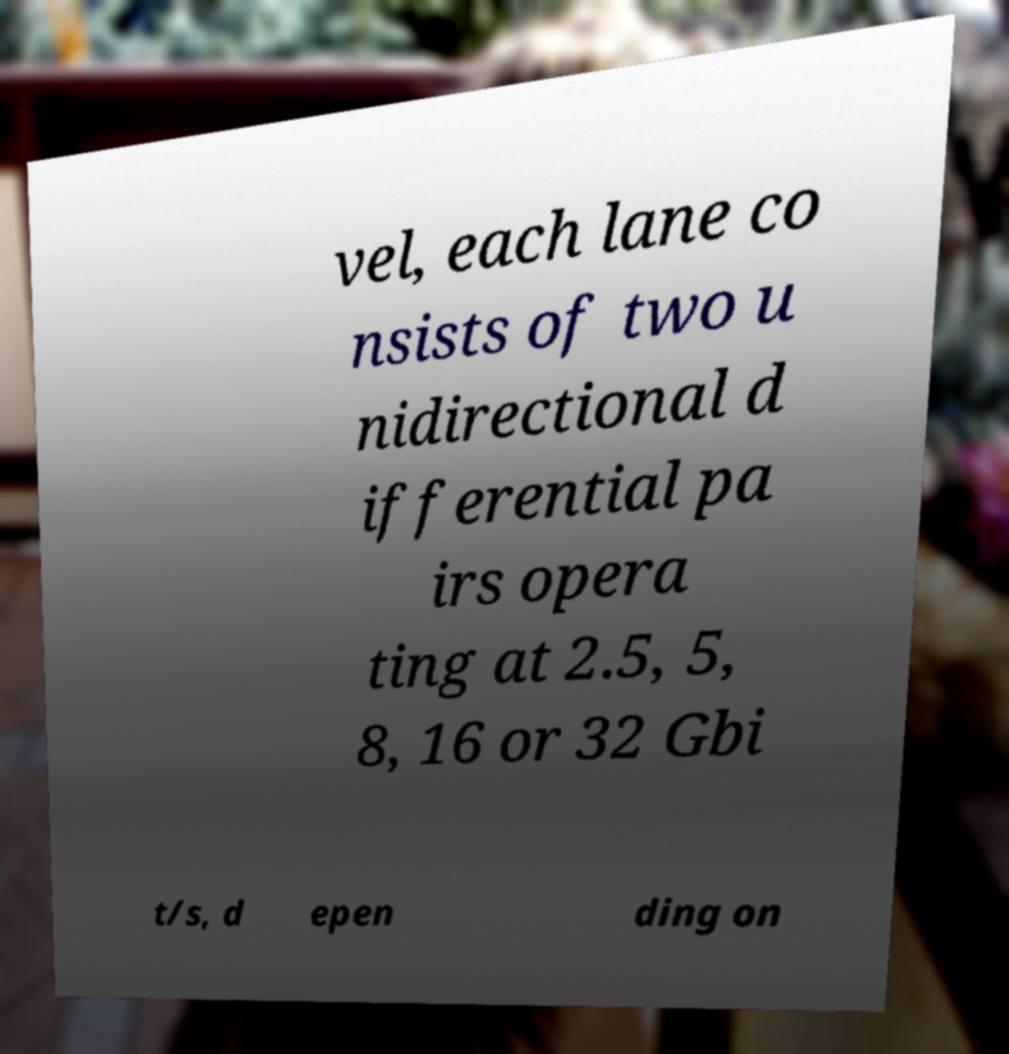What messages or text are displayed in this image? I need them in a readable, typed format. vel, each lane co nsists of two u nidirectional d ifferential pa irs opera ting at 2.5, 5, 8, 16 or 32 Gbi t/s, d epen ding on 